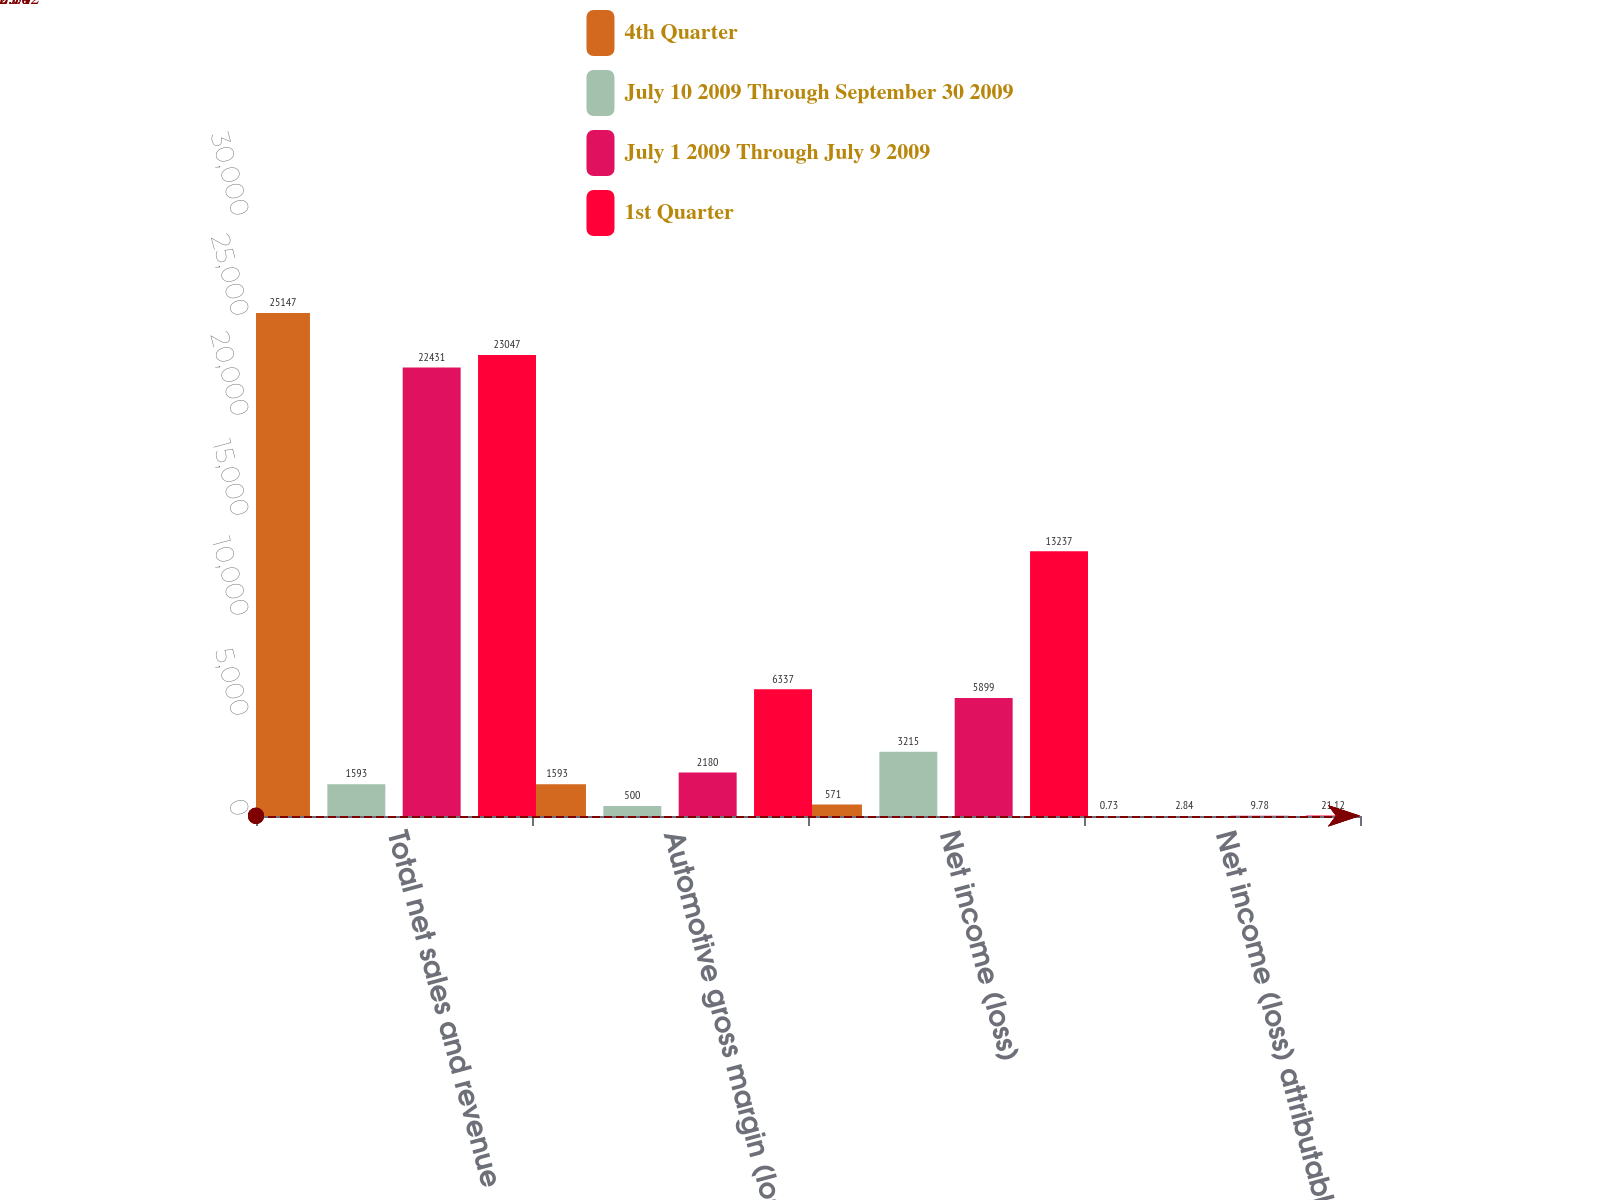Convert chart to OTSL. <chart><loc_0><loc_0><loc_500><loc_500><stacked_bar_chart><ecel><fcel>Total net sales and revenue<fcel>Automotive gross margin (loss)<fcel>Net income (loss)<fcel>Net income (loss) attributable<nl><fcel>4th Quarter<fcel>25147<fcel>1593<fcel>571<fcel>0.73<nl><fcel>July 10 2009 Through September 30 2009<fcel>1593<fcel>500<fcel>3215<fcel>2.84<nl><fcel>July 1 2009 Through July 9 2009<fcel>22431<fcel>2180<fcel>5899<fcel>9.78<nl><fcel>1st Quarter<fcel>23047<fcel>6337<fcel>13237<fcel>21.12<nl></chart> 